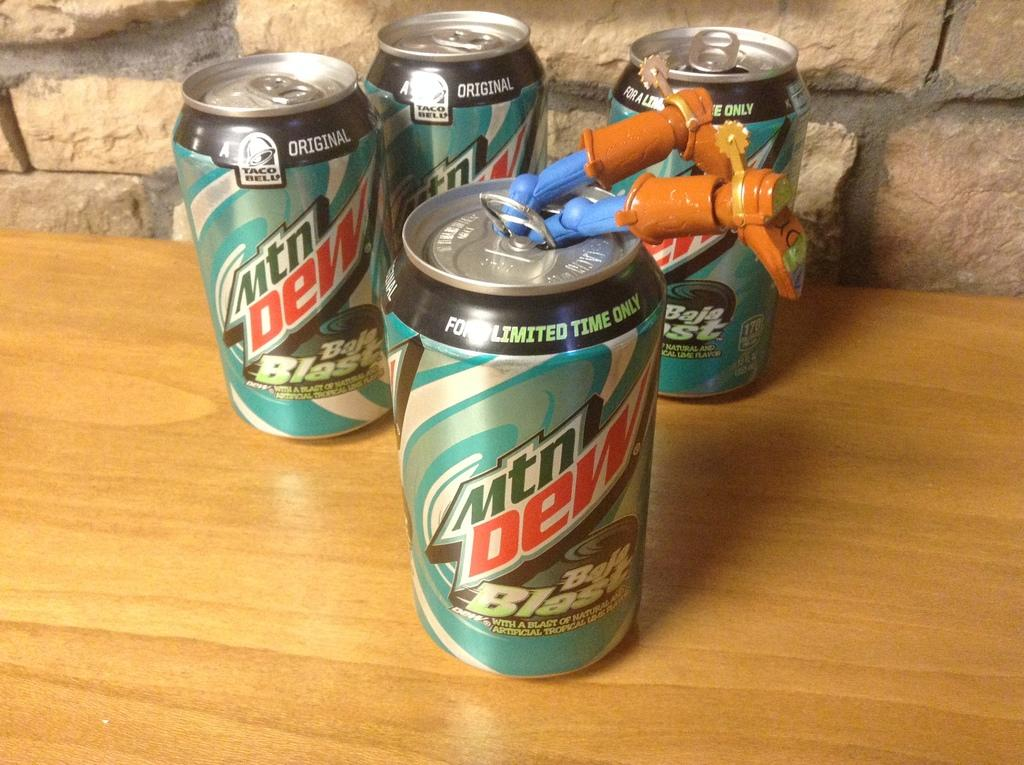<image>
Summarize the visual content of the image. Several cans of mountain Dew with what appears to be woody from Toy Story hanging out. 